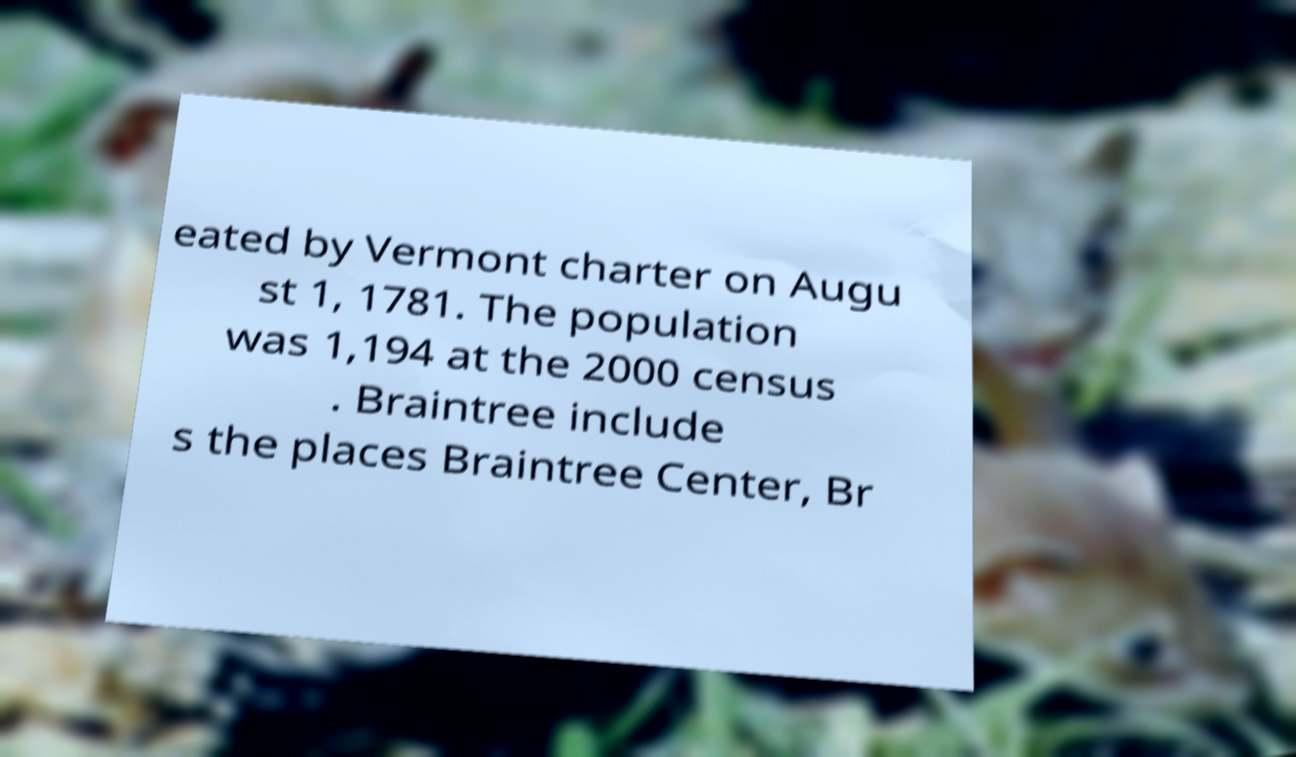Could you assist in decoding the text presented in this image and type it out clearly? eated by Vermont charter on Augu st 1, 1781. The population was 1,194 at the 2000 census . Braintree include s the places Braintree Center, Br 